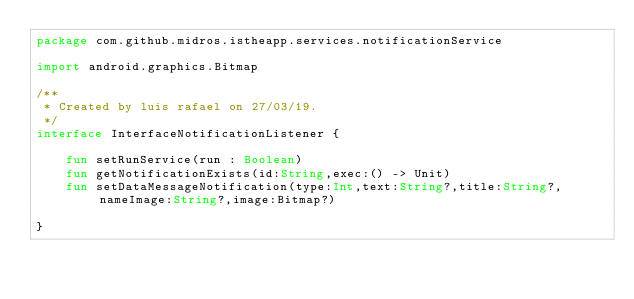<code> <loc_0><loc_0><loc_500><loc_500><_Kotlin_>package com.github.midros.istheapp.services.notificationService

import android.graphics.Bitmap

/**
 * Created by luis rafael on 27/03/19.
 */
interface InterfaceNotificationListener {

    fun setRunService(run : Boolean)
    fun getNotificationExists(id:String,exec:() -> Unit)
    fun setDataMessageNotification(type:Int,text:String?,title:String?,nameImage:String?,image:Bitmap?)

}</code> 